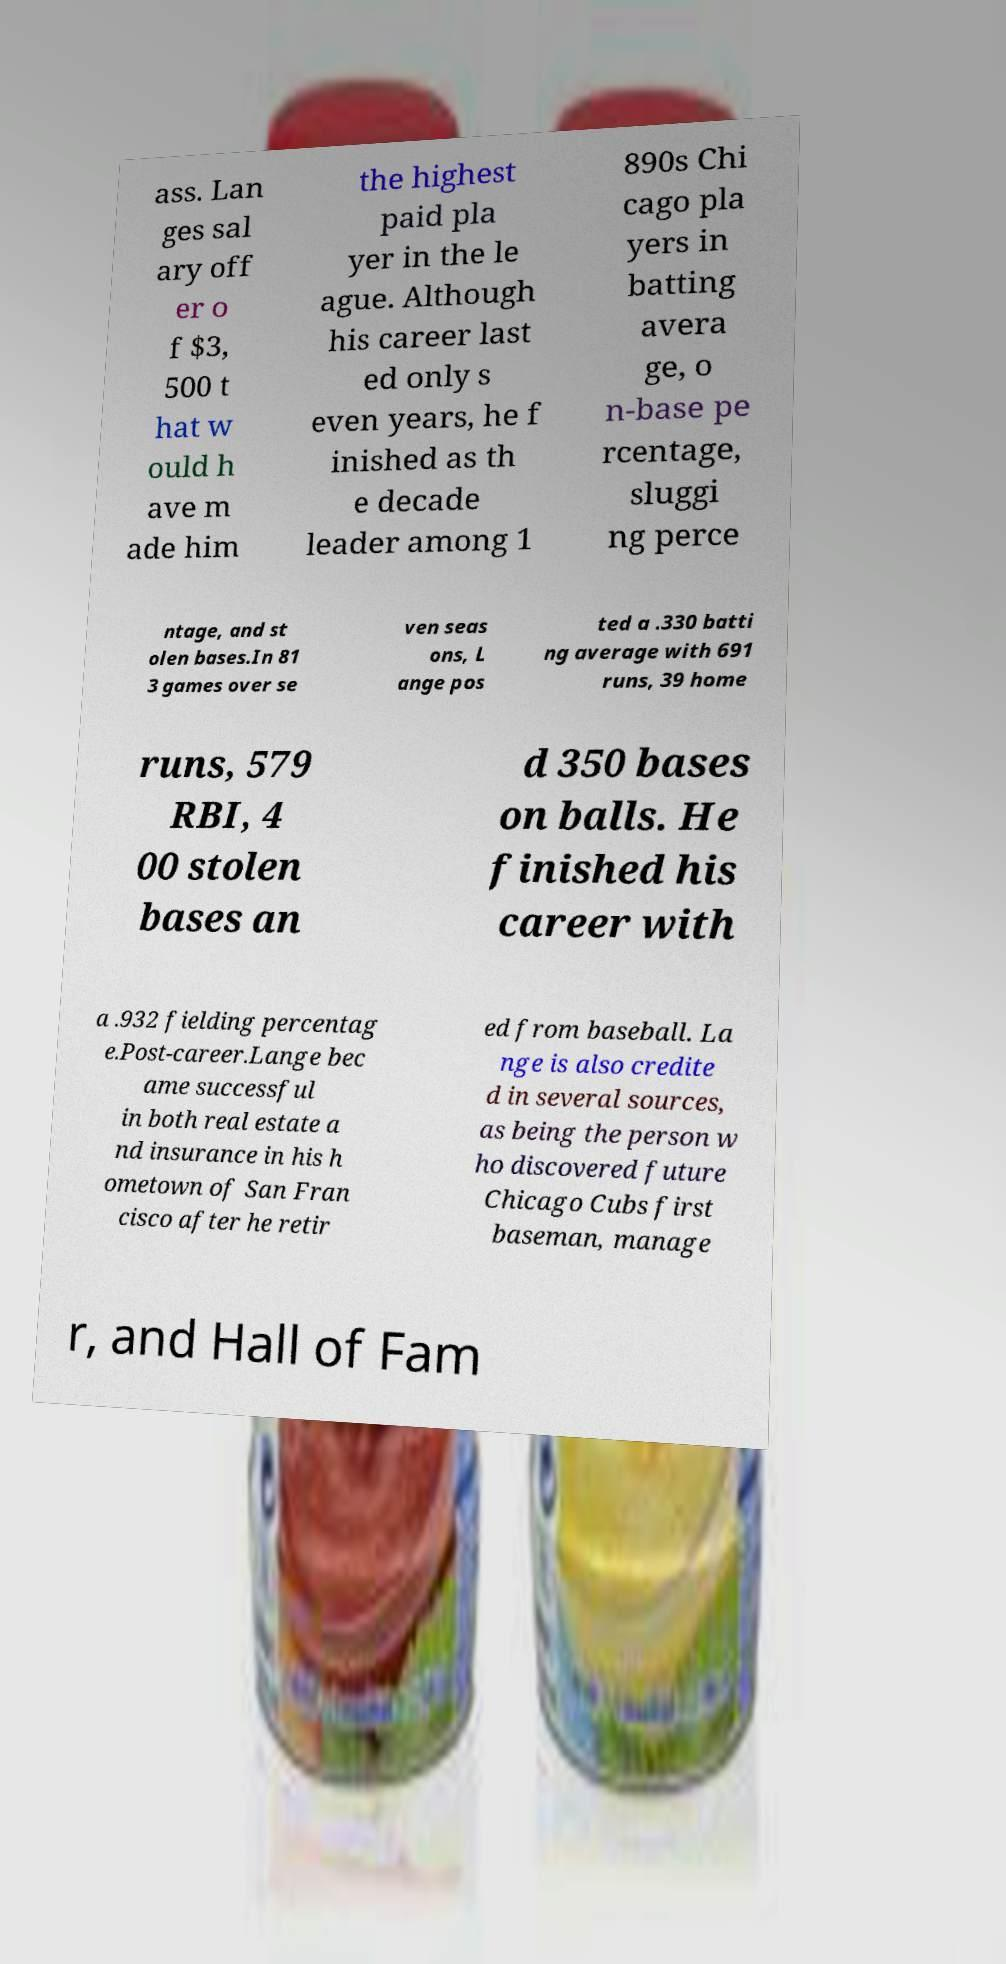Could you assist in decoding the text presented in this image and type it out clearly? ass. Lan ges sal ary off er o f $3, 500 t hat w ould h ave m ade him the highest paid pla yer in the le ague. Although his career last ed only s even years, he f inished as th e decade leader among 1 890s Chi cago pla yers in batting avera ge, o n-base pe rcentage, sluggi ng perce ntage, and st olen bases.In 81 3 games over se ven seas ons, L ange pos ted a .330 batti ng average with 691 runs, 39 home runs, 579 RBI, 4 00 stolen bases an d 350 bases on balls. He finished his career with a .932 fielding percentag e.Post-career.Lange bec ame successful in both real estate a nd insurance in his h ometown of San Fran cisco after he retir ed from baseball. La nge is also credite d in several sources, as being the person w ho discovered future Chicago Cubs first baseman, manage r, and Hall of Fam 